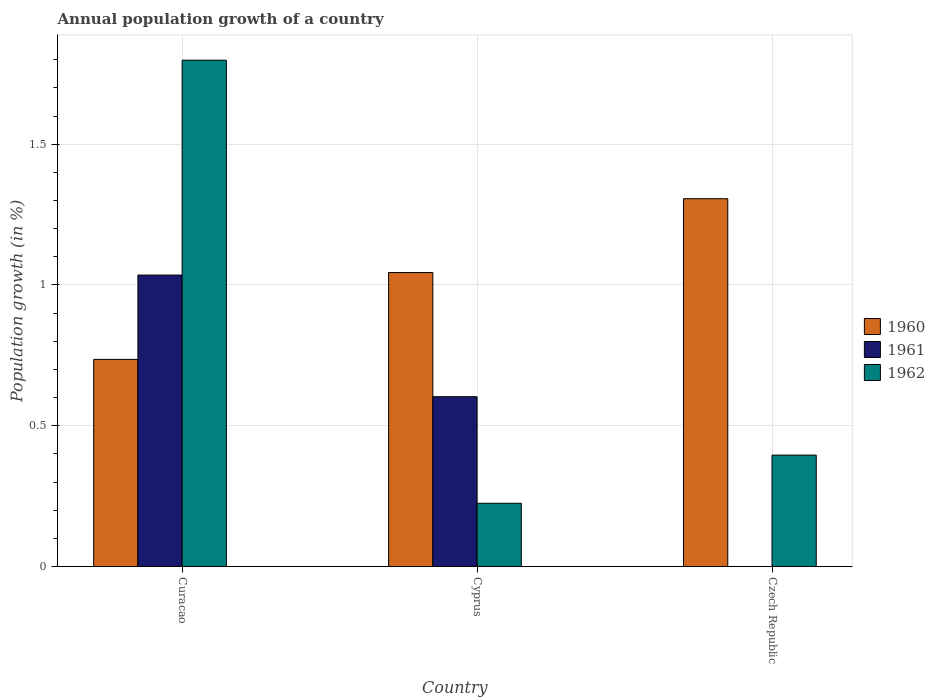How many different coloured bars are there?
Offer a very short reply. 3. Are the number of bars per tick equal to the number of legend labels?
Your answer should be very brief. No. Are the number of bars on each tick of the X-axis equal?
Provide a short and direct response. No. How many bars are there on the 3rd tick from the left?
Your response must be concise. 2. What is the label of the 2nd group of bars from the left?
Your response must be concise. Cyprus. What is the annual population growth in 1962 in Curacao?
Offer a terse response. 1.8. Across all countries, what is the maximum annual population growth in 1962?
Provide a succinct answer. 1.8. Across all countries, what is the minimum annual population growth in 1960?
Offer a very short reply. 0.74. In which country was the annual population growth in 1960 maximum?
Provide a succinct answer. Czech Republic. What is the total annual population growth in 1961 in the graph?
Offer a terse response. 1.64. What is the difference between the annual population growth in 1960 in Curacao and that in Cyprus?
Provide a short and direct response. -0.31. What is the difference between the annual population growth in 1960 in Czech Republic and the annual population growth in 1961 in Curacao?
Give a very brief answer. 0.27. What is the average annual population growth in 1960 per country?
Your answer should be very brief. 1.03. What is the difference between the annual population growth of/in 1960 and annual population growth of/in 1962 in Curacao?
Provide a short and direct response. -1.06. What is the ratio of the annual population growth in 1960 in Curacao to that in Czech Republic?
Give a very brief answer. 0.56. Is the annual population growth in 1962 in Curacao less than that in Czech Republic?
Give a very brief answer. No. What is the difference between the highest and the second highest annual population growth in 1962?
Give a very brief answer. -1.4. What is the difference between the highest and the lowest annual population growth in 1961?
Make the answer very short. 1.04. In how many countries, is the annual population growth in 1961 greater than the average annual population growth in 1961 taken over all countries?
Your answer should be compact. 2. What is the difference between two consecutive major ticks on the Y-axis?
Provide a short and direct response. 0.5. Are the values on the major ticks of Y-axis written in scientific E-notation?
Offer a terse response. No. Does the graph contain grids?
Provide a short and direct response. Yes. Where does the legend appear in the graph?
Provide a succinct answer. Center right. How are the legend labels stacked?
Make the answer very short. Vertical. What is the title of the graph?
Provide a succinct answer. Annual population growth of a country. What is the label or title of the X-axis?
Ensure brevity in your answer.  Country. What is the label or title of the Y-axis?
Your response must be concise. Population growth (in %). What is the Population growth (in %) of 1960 in Curacao?
Give a very brief answer. 0.74. What is the Population growth (in %) in 1961 in Curacao?
Offer a terse response. 1.04. What is the Population growth (in %) of 1962 in Curacao?
Provide a succinct answer. 1.8. What is the Population growth (in %) in 1960 in Cyprus?
Your response must be concise. 1.04. What is the Population growth (in %) of 1961 in Cyprus?
Ensure brevity in your answer.  0.6. What is the Population growth (in %) in 1962 in Cyprus?
Provide a succinct answer. 0.22. What is the Population growth (in %) of 1960 in Czech Republic?
Offer a very short reply. 1.31. What is the Population growth (in %) of 1961 in Czech Republic?
Offer a very short reply. 0. What is the Population growth (in %) of 1962 in Czech Republic?
Your response must be concise. 0.4. Across all countries, what is the maximum Population growth (in %) in 1960?
Your answer should be compact. 1.31. Across all countries, what is the maximum Population growth (in %) of 1961?
Give a very brief answer. 1.04. Across all countries, what is the maximum Population growth (in %) of 1962?
Give a very brief answer. 1.8. Across all countries, what is the minimum Population growth (in %) in 1960?
Give a very brief answer. 0.74. Across all countries, what is the minimum Population growth (in %) in 1962?
Your answer should be compact. 0.22. What is the total Population growth (in %) of 1960 in the graph?
Make the answer very short. 3.09. What is the total Population growth (in %) of 1961 in the graph?
Give a very brief answer. 1.64. What is the total Population growth (in %) in 1962 in the graph?
Offer a terse response. 2.42. What is the difference between the Population growth (in %) of 1960 in Curacao and that in Cyprus?
Make the answer very short. -0.31. What is the difference between the Population growth (in %) of 1961 in Curacao and that in Cyprus?
Provide a succinct answer. 0.43. What is the difference between the Population growth (in %) of 1962 in Curacao and that in Cyprus?
Ensure brevity in your answer.  1.57. What is the difference between the Population growth (in %) of 1960 in Curacao and that in Czech Republic?
Your answer should be compact. -0.57. What is the difference between the Population growth (in %) of 1962 in Curacao and that in Czech Republic?
Offer a very short reply. 1.4. What is the difference between the Population growth (in %) in 1960 in Cyprus and that in Czech Republic?
Your answer should be compact. -0.26. What is the difference between the Population growth (in %) of 1962 in Cyprus and that in Czech Republic?
Ensure brevity in your answer.  -0.17. What is the difference between the Population growth (in %) in 1960 in Curacao and the Population growth (in %) in 1961 in Cyprus?
Your answer should be compact. 0.13. What is the difference between the Population growth (in %) of 1960 in Curacao and the Population growth (in %) of 1962 in Cyprus?
Provide a short and direct response. 0.51. What is the difference between the Population growth (in %) in 1961 in Curacao and the Population growth (in %) in 1962 in Cyprus?
Offer a very short reply. 0.81. What is the difference between the Population growth (in %) in 1960 in Curacao and the Population growth (in %) in 1962 in Czech Republic?
Your answer should be compact. 0.34. What is the difference between the Population growth (in %) in 1961 in Curacao and the Population growth (in %) in 1962 in Czech Republic?
Offer a terse response. 0.64. What is the difference between the Population growth (in %) of 1960 in Cyprus and the Population growth (in %) of 1962 in Czech Republic?
Keep it short and to the point. 0.65. What is the difference between the Population growth (in %) in 1961 in Cyprus and the Population growth (in %) in 1962 in Czech Republic?
Ensure brevity in your answer.  0.21. What is the average Population growth (in %) in 1960 per country?
Your answer should be compact. 1.03. What is the average Population growth (in %) of 1961 per country?
Keep it short and to the point. 0.55. What is the average Population growth (in %) of 1962 per country?
Offer a terse response. 0.81. What is the difference between the Population growth (in %) of 1960 and Population growth (in %) of 1961 in Curacao?
Make the answer very short. -0.3. What is the difference between the Population growth (in %) in 1960 and Population growth (in %) in 1962 in Curacao?
Give a very brief answer. -1.06. What is the difference between the Population growth (in %) in 1961 and Population growth (in %) in 1962 in Curacao?
Offer a very short reply. -0.76. What is the difference between the Population growth (in %) of 1960 and Population growth (in %) of 1961 in Cyprus?
Make the answer very short. 0.44. What is the difference between the Population growth (in %) in 1960 and Population growth (in %) in 1962 in Cyprus?
Your response must be concise. 0.82. What is the difference between the Population growth (in %) of 1961 and Population growth (in %) of 1962 in Cyprus?
Ensure brevity in your answer.  0.38. What is the difference between the Population growth (in %) of 1960 and Population growth (in %) of 1962 in Czech Republic?
Ensure brevity in your answer.  0.91. What is the ratio of the Population growth (in %) of 1960 in Curacao to that in Cyprus?
Give a very brief answer. 0.7. What is the ratio of the Population growth (in %) of 1961 in Curacao to that in Cyprus?
Offer a terse response. 1.72. What is the ratio of the Population growth (in %) in 1962 in Curacao to that in Cyprus?
Provide a succinct answer. 8.01. What is the ratio of the Population growth (in %) in 1960 in Curacao to that in Czech Republic?
Ensure brevity in your answer.  0.56. What is the ratio of the Population growth (in %) in 1962 in Curacao to that in Czech Republic?
Ensure brevity in your answer.  4.55. What is the ratio of the Population growth (in %) in 1960 in Cyprus to that in Czech Republic?
Your answer should be compact. 0.8. What is the ratio of the Population growth (in %) in 1962 in Cyprus to that in Czech Republic?
Your answer should be very brief. 0.57. What is the difference between the highest and the second highest Population growth (in %) of 1960?
Your answer should be compact. 0.26. What is the difference between the highest and the second highest Population growth (in %) in 1962?
Your response must be concise. 1.4. What is the difference between the highest and the lowest Population growth (in %) of 1960?
Offer a terse response. 0.57. What is the difference between the highest and the lowest Population growth (in %) of 1961?
Make the answer very short. 1.04. What is the difference between the highest and the lowest Population growth (in %) of 1962?
Offer a very short reply. 1.57. 